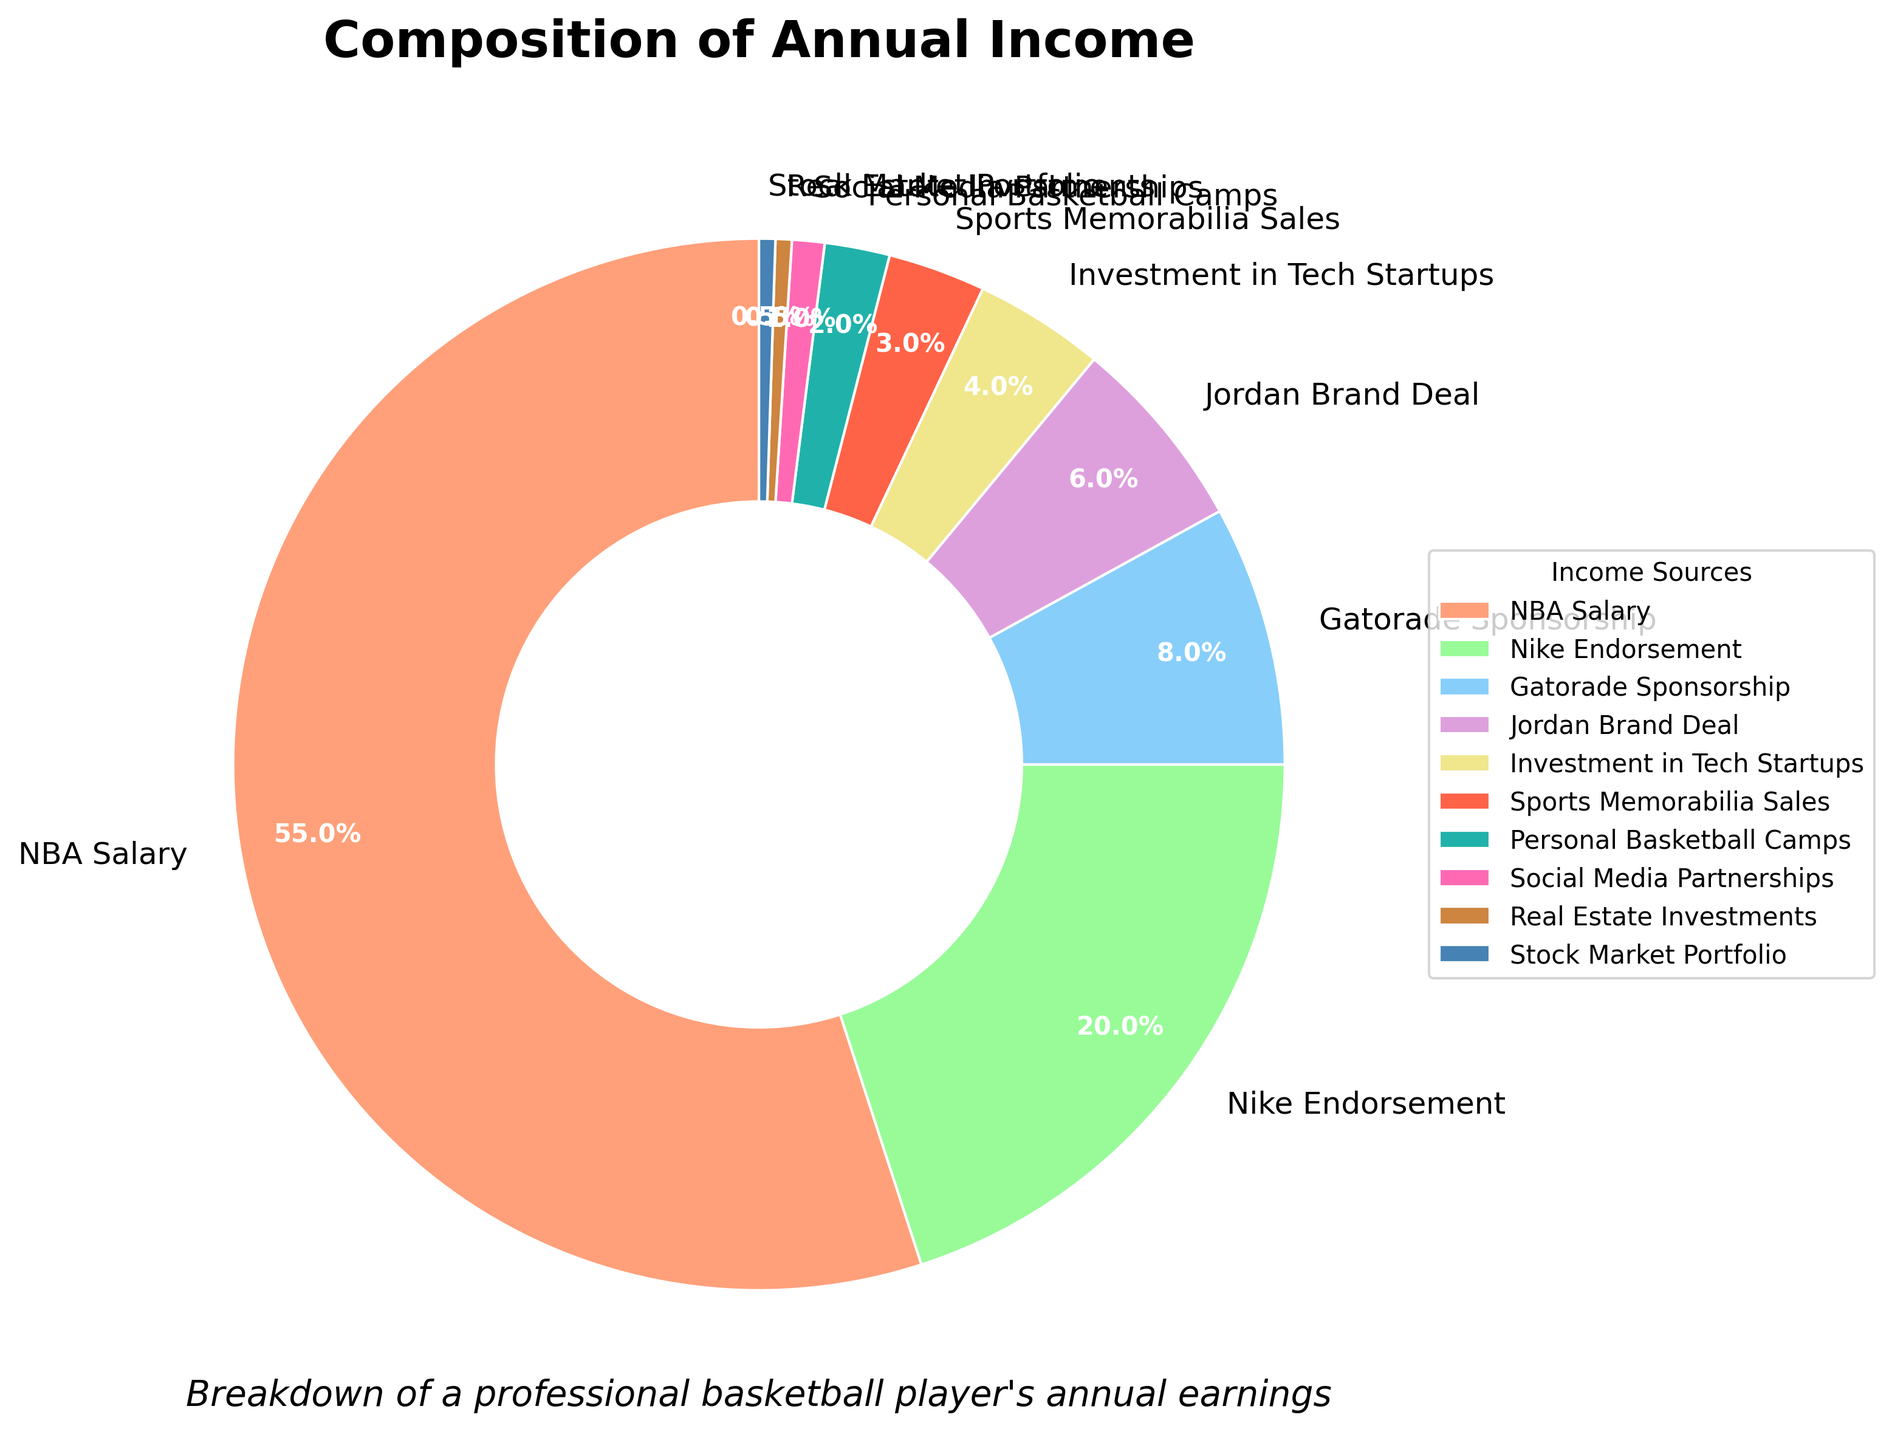Which income source contributes the most to the annual income? By inspecting the pie chart, the largest section of the chart is clearly labeled "NBA Salary," indicating that it contributes the most to the annual income.
Answer: NBA Salary What percentage of income comes from endorsements combined (Nike, Gatorade, Jordan)? Sum the percentages of Nike Endorsement (20%), Gatorade Sponsorship (8%), and Jordan Brand Deal (6%). So, 20% + 8% + 6% = 34%.
Answer: 34% How does the income from investments (Tech Startups + Real Estate + Stock Market) compare to the income from endorsements? The income from investments is calculated by summing Investment in Tech Startups (4%), Real Estate Investments (0.5%), and Stock Market Portfolio (0.5%), giving a total of 4% + 0.5% + 0.5% = 5%. The income from endorsements is 34%. Therefore, 5% is less than 34%.
Answer: Less Does any single income source contribute less than 1%? If so, which one(s)? By looking at the pie chart, both Social Media Partnerships (1%) and Stock Market Portfolio (0.5%) contribute less than 1%.
Answer: Stock Market Portfolio Which two income sources together comprise approximately one-fourth of the total income? By assessing the pie chart, Nike Endorsement (20%) and Personal Basketball Camps (2%) sum to 20% + 2% = 22%, sports Memorabilia Sales (3%) and Jordan Brand Deal (6%) sum to 3% + 6% = 9%, Nike Endorsement (20%) and Jordan Brand Deal (6%) sum to 20% + 6% = 26%. The value closest to one-fourth (25%) is 26%.
Answer: Nike Endorsement and Jordan Brand Deal What is the visual difference between the categories that make up more than 50% and those that make up less than 5%? The sections representing NBA Salary, which makes up 55%, are visually larger and more conspicuous, whereas sections like Real Estate Investments, Stock Market Portfolio, and others under 5% are minor and less noticeable on the pie chart.
Answer: Larger and more conspicuous vs. smaller and less noticeable What is the combined percentage for Sports Memorabilia Sales and Personal Basketball Camps? Sum the percentages of Sports Memorabilia Sales (3%) and Personal Basketball Camps (2%). So, 3% + 2% = 5%.
Answer: 5% Which income source's percentage is closest to the sum of Real Estate Investments and Stock Market Portfolio? The sum of Real Estate Investments (0.5%) and Stock Market Portfolio (0.5%) is 1%. The closest percentage to 1% is Social Media Partnerships at 1%.
Answer: Social Media Partnerships How does the income from Gatorade compare against the one from Jordan? By comparing the percentages, Gatorade Sponsorship contributes 8% and Jordan Brand Deal contributes 6%, meaning Gatorade provides more income.
Answer: Gatorade provides more 